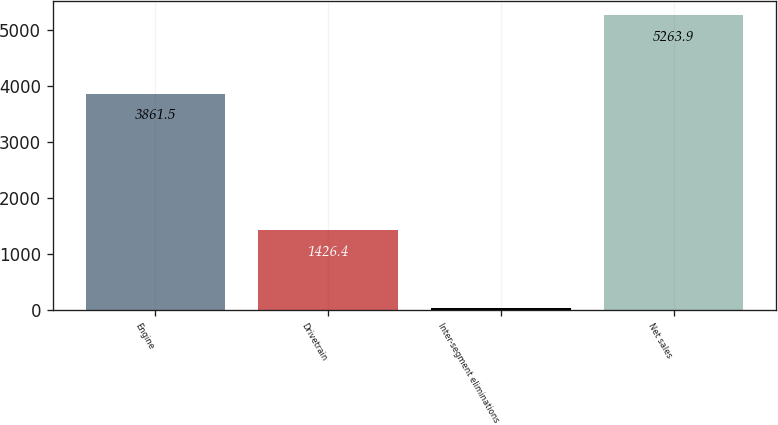Convert chart. <chart><loc_0><loc_0><loc_500><loc_500><bar_chart><fcel>Engine<fcel>Drivetrain<fcel>Inter-segment eliminations<fcel>Net sales<nl><fcel>3861.5<fcel>1426.4<fcel>24<fcel>5263.9<nl></chart> 